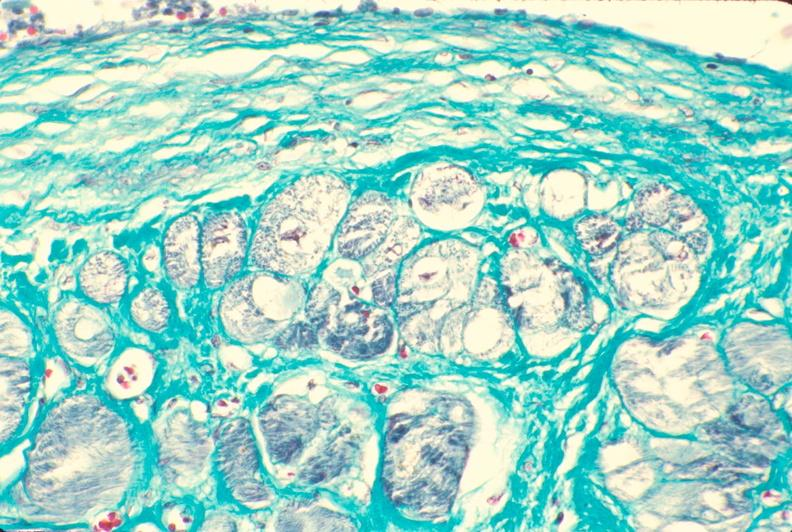s cardiovascular present?
Answer the question using a single word or phrase. Yes 